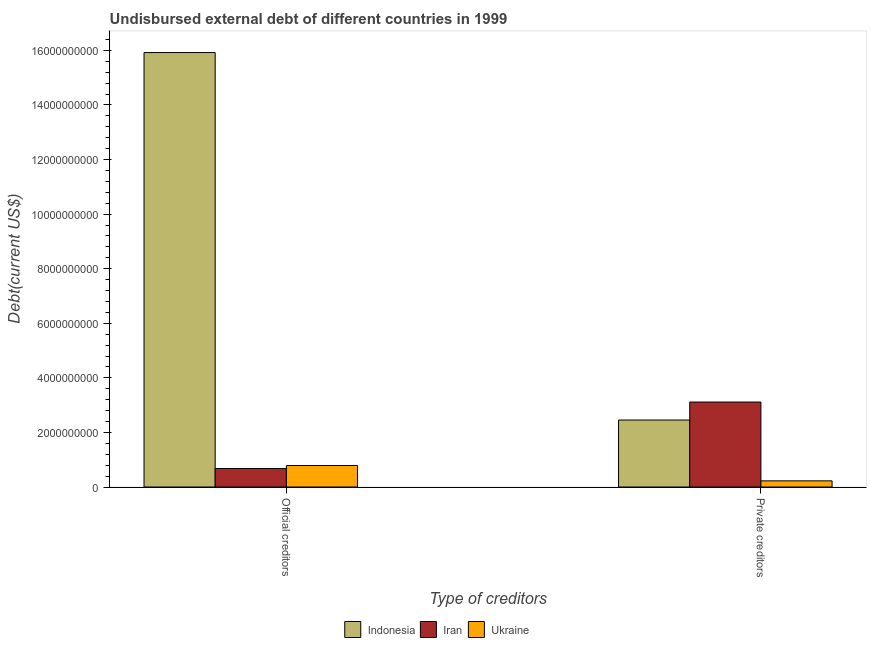How many different coloured bars are there?
Ensure brevity in your answer.  3. How many groups of bars are there?
Give a very brief answer. 2. Are the number of bars on each tick of the X-axis equal?
Your response must be concise. Yes. How many bars are there on the 2nd tick from the left?
Provide a succinct answer. 3. How many bars are there on the 1st tick from the right?
Offer a terse response. 3. What is the label of the 2nd group of bars from the left?
Your answer should be compact. Private creditors. What is the undisbursed external debt of official creditors in Ukraine?
Your answer should be very brief. 7.88e+08. Across all countries, what is the maximum undisbursed external debt of official creditors?
Make the answer very short. 1.59e+1. Across all countries, what is the minimum undisbursed external debt of private creditors?
Keep it short and to the point. 2.26e+08. In which country was the undisbursed external debt of official creditors minimum?
Give a very brief answer. Iran. What is the total undisbursed external debt of official creditors in the graph?
Give a very brief answer. 1.74e+1. What is the difference between the undisbursed external debt of private creditors in Ukraine and that in Iran?
Make the answer very short. -2.89e+09. What is the difference between the undisbursed external debt of official creditors in Iran and the undisbursed external debt of private creditors in Indonesia?
Offer a terse response. -1.78e+09. What is the average undisbursed external debt of private creditors per country?
Make the answer very short. 1.93e+09. What is the difference between the undisbursed external debt of private creditors and undisbursed external debt of official creditors in Iran?
Ensure brevity in your answer.  2.44e+09. What is the ratio of the undisbursed external debt of official creditors in Ukraine to that in Indonesia?
Your answer should be compact. 0.05. What does the 2nd bar from the left in Private creditors represents?
Your answer should be very brief. Iran. What does the 3rd bar from the right in Private creditors represents?
Offer a very short reply. Indonesia. How many bars are there?
Offer a terse response. 6. Are all the bars in the graph horizontal?
Make the answer very short. No. How many countries are there in the graph?
Provide a short and direct response. 3. What is the difference between two consecutive major ticks on the Y-axis?
Your answer should be compact. 2.00e+09. Are the values on the major ticks of Y-axis written in scientific E-notation?
Provide a short and direct response. No. Does the graph contain grids?
Make the answer very short. No. What is the title of the graph?
Keep it short and to the point. Undisbursed external debt of different countries in 1999. Does "Croatia" appear as one of the legend labels in the graph?
Give a very brief answer. No. What is the label or title of the X-axis?
Your answer should be compact. Type of creditors. What is the label or title of the Y-axis?
Offer a very short reply. Debt(current US$). What is the Debt(current US$) of Indonesia in Official creditors?
Ensure brevity in your answer.  1.59e+1. What is the Debt(current US$) of Iran in Official creditors?
Give a very brief answer. 6.77e+08. What is the Debt(current US$) of Ukraine in Official creditors?
Ensure brevity in your answer.  7.88e+08. What is the Debt(current US$) of Indonesia in Private creditors?
Keep it short and to the point. 2.45e+09. What is the Debt(current US$) of Iran in Private creditors?
Your answer should be very brief. 3.11e+09. What is the Debt(current US$) in Ukraine in Private creditors?
Provide a succinct answer. 2.26e+08. Across all Type of creditors, what is the maximum Debt(current US$) of Indonesia?
Your answer should be compact. 1.59e+1. Across all Type of creditors, what is the maximum Debt(current US$) in Iran?
Provide a succinct answer. 3.11e+09. Across all Type of creditors, what is the maximum Debt(current US$) of Ukraine?
Give a very brief answer. 7.88e+08. Across all Type of creditors, what is the minimum Debt(current US$) in Indonesia?
Make the answer very short. 2.45e+09. Across all Type of creditors, what is the minimum Debt(current US$) of Iran?
Your answer should be compact. 6.77e+08. Across all Type of creditors, what is the minimum Debt(current US$) in Ukraine?
Keep it short and to the point. 2.26e+08. What is the total Debt(current US$) in Indonesia in the graph?
Your answer should be compact. 1.84e+1. What is the total Debt(current US$) in Iran in the graph?
Provide a succinct answer. 3.79e+09. What is the total Debt(current US$) of Ukraine in the graph?
Offer a very short reply. 1.01e+09. What is the difference between the Debt(current US$) of Indonesia in Official creditors and that in Private creditors?
Provide a succinct answer. 1.35e+1. What is the difference between the Debt(current US$) of Iran in Official creditors and that in Private creditors?
Ensure brevity in your answer.  -2.44e+09. What is the difference between the Debt(current US$) of Ukraine in Official creditors and that in Private creditors?
Provide a short and direct response. 5.62e+08. What is the difference between the Debt(current US$) in Indonesia in Official creditors and the Debt(current US$) in Iran in Private creditors?
Offer a very short reply. 1.28e+1. What is the difference between the Debt(current US$) of Indonesia in Official creditors and the Debt(current US$) of Ukraine in Private creditors?
Offer a terse response. 1.57e+1. What is the difference between the Debt(current US$) in Iran in Official creditors and the Debt(current US$) in Ukraine in Private creditors?
Keep it short and to the point. 4.51e+08. What is the average Debt(current US$) in Indonesia per Type of creditors?
Give a very brief answer. 9.19e+09. What is the average Debt(current US$) in Iran per Type of creditors?
Provide a short and direct response. 1.90e+09. What is the average Debt(current US$) in Ukraine per Type of creditors?
Ensure brevity in your answer.  5.07e+08. What is the difference between the Debt(current US$) of Indonesia and Debt(current US$) of Iran in Official creditors?
Your response must be concise. 1.52e+1. What is the difference between the Debt(current US$) of Indonesia and Debt(current US$) of Ukraine in Official creditors?
Provide a short and direct response. 1.51e+1. What is the difference between the Debt(current US$) in Iran and Debt(current US$) in Ukraine in Official creditors?
Provide a short and direct response. -1.10e+08. What is the difference between the Debt(current US$) in Indonesia and Debt(current US$) in Iran in Private creditors?
Your response must be concise. -6.59e+08. What is the difference between the Debt(current US$) of Indonesia and Debt(current US$) of Ukraine in Private creditors?
Ensure brevity in your answer.  2.23e+09. What is the difference between the Debt(current US$) in Iran and Debt(current US$) in Ukraine in Private creditors?
Your answer should be compact. 2.89e+09. What is the ratio of the Debt(current US$) in Indonesia in Official creditors to that in Private creditors?
Make the answer very short. 6.49. What is the ratio of the Debt(current US$) in Iran in Official creditors to that in Private creditors?
Make the answer very short. 0.22. What is the ratio of the Debt(current US$) of Ukraine in Official creditors to that in Private creditors?
Your response must be concise. 3.49. What is the difference between the highest and the second highest Debt(current US$) in Indonesia?
Ensure brevity in your answer.  1.35e+1. What is the difference between the highest and the second highest Debt(current US$) of Iran?
Your response must be concise. 2.44e+09. What is the difference between the highest and the second highest Debt(current US$) in Ukraine?
Provide a short and direct response. 5.62e+08. What is the difference between the highest and the lowest Debt(current US$) in Indonesia?
Provide a succinct answer. 1.35e+1. What is the difference between the highest and the lowest Debt(current US$) in Iran?
Provide a short and direct response. 2.44e+09. What is the difference between the highest and the lowest Debt(current US$) in Ukraine?
Give a very brief answer. 5.62e+08. 